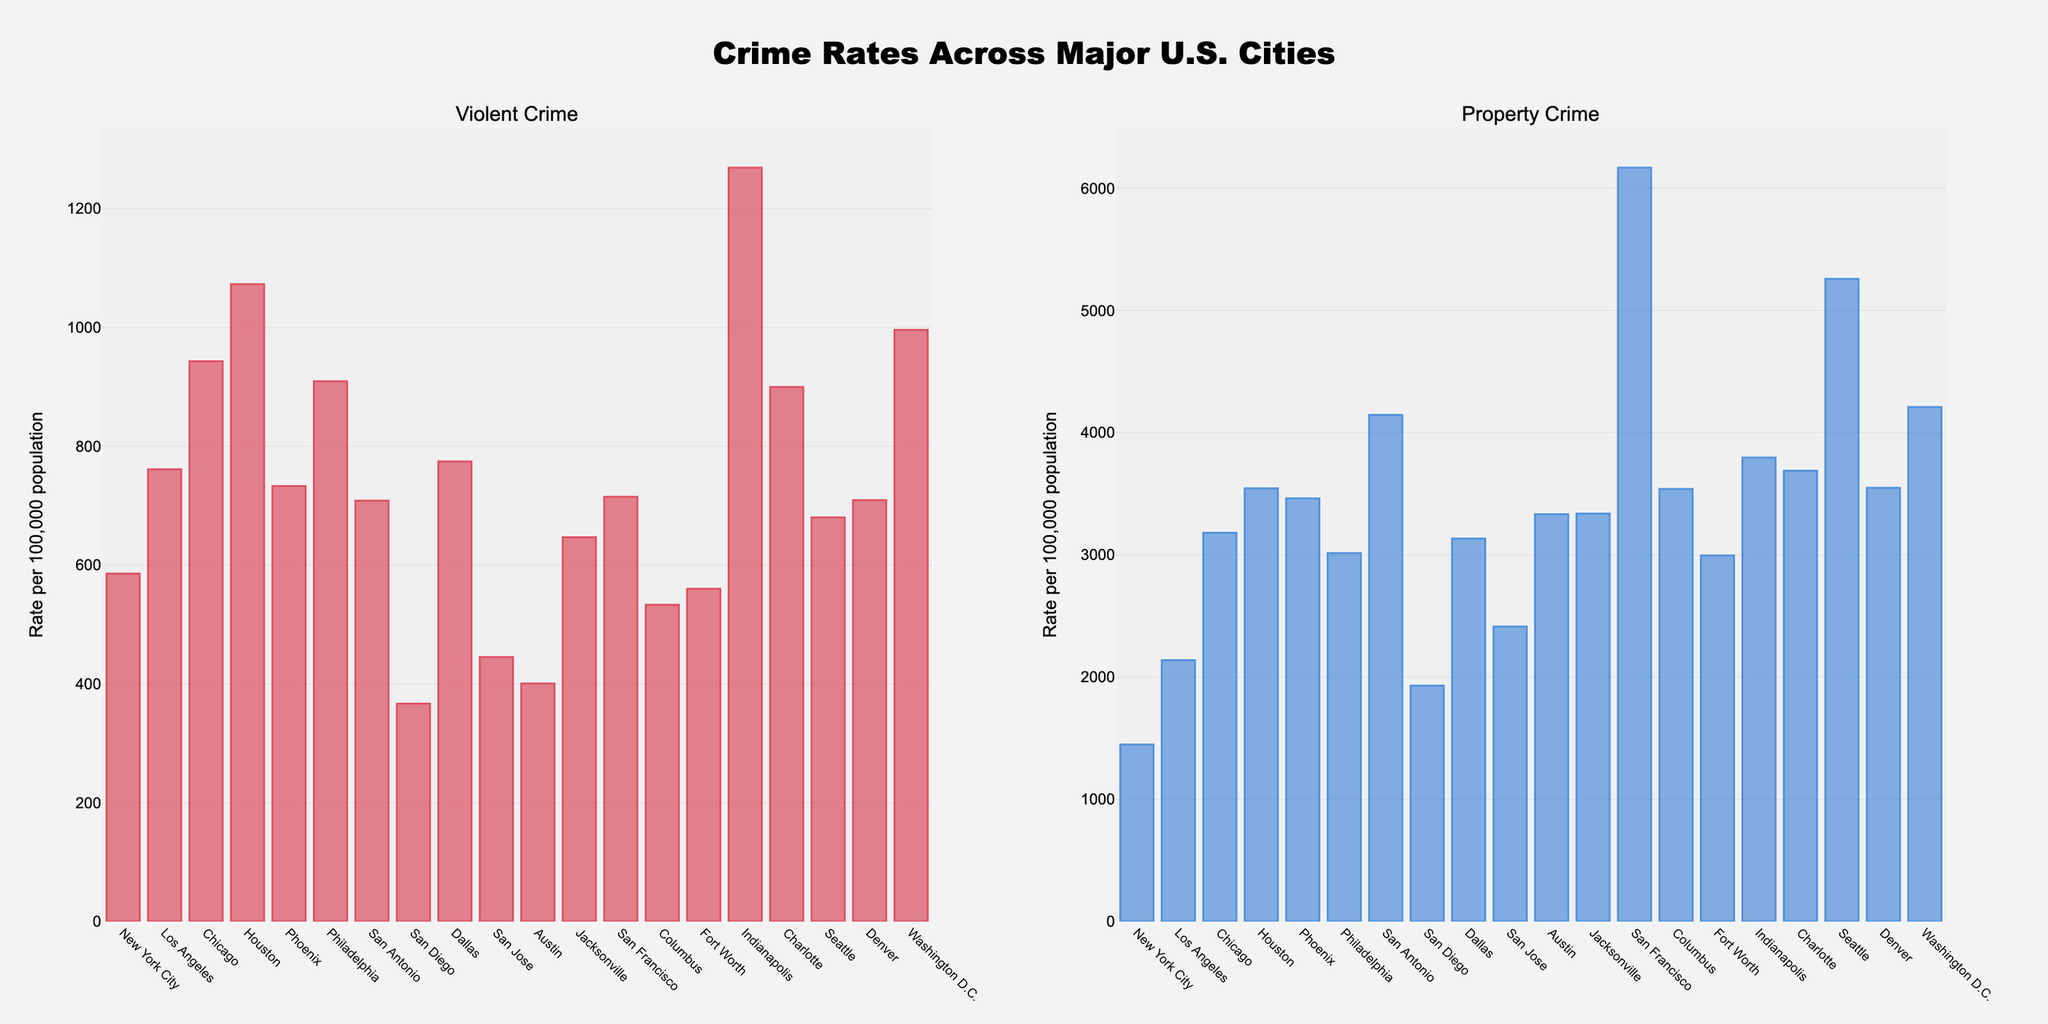Which city has the highest rate of violent crime? Look at the bar corresponding to Violent Crime for each city. The tallest bar represents the highest violent crime rate. Houston has the highest rate.
Answer: Houston Which city shows the lowest property crime rate? Check the bar representing Property Crime for each city. The shortest bar indicates the lowest property crime rate. San Diego has the lowest rate.
Answer: San Diego What is the difference in property crime rates between San Francisco and Seattle? Identify the bars for property crime in San Francisco and Seattle. San Francisco's bar is higher, representing a rate of 6168.2, while Seattle's rate is 5258.0. The difference is 6168.2 - 5258.0.
Answer: 910.2 On average, which crime type (Violent Crime or Property Crime) appears to have higher rates across the cities? Calculate the average height of bars for each crime type. Sum the rates for each city then divide by the number of cities for both crime types. Property crime bars are consistently higher.
Answer: Property Crime Is there any city where the rate of violent crime is significantly lower than property crime? Check the bars for each city and compare the heights. Significant differences will show a much shorter violent crime bar than the property crime bar. San Diego has a rate of 366.9 for violent crime and 1931.3 for property crime, indicating a significant difference.
Answer: San Diego Which city has a more balanced rate between violent and property crimes? Identify cities where the heights of the bars for violent and property crimes are similar. Compare these pairs to find the closest match. Austin's bars for violent (400.8) and property crimes (3332.5) differ by 2931.7.
Answer: Austin How much higher is the property crime rate in San Antonio compared to San Jose? Property crime rate for San Antonio is 4145.3 and for San Jose, it is 2413.4. Subtract San Jose's rate from San Antonio's rate. 4145.3 - 2413.4 equals 1731.9.
Answer: 1731.9 Which cities have a violent crime rate above 900? Look for bars taller than the 900 mark for violent crime. Chicago (943.2), Philadelphia (909.4), Washington D.C. (995.9), and Charlotte (899.7, but slightly below) fit this criterion.
Answer: Chicago, Philadelphia, Washington D.C What city has the most significant gap between violent and property crime rates? For each city, subtract the violent crime rate from the property crime rate and compare these differences. San Francisco has violent crime at 715.0 and property crime at 6168.2, a gap of 5453.2, the highest difference.
Answer: San Francisco 